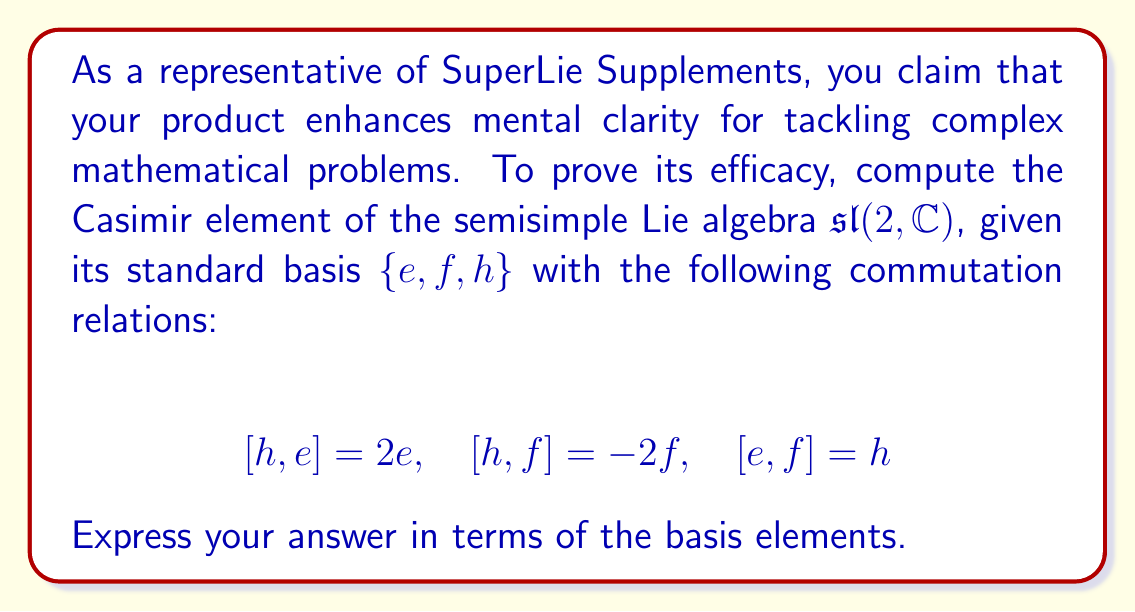Show me your answer to this math problem. To compute the Casimir element of $\mathfrak{sl}(2,\mathbb{C})$, we follow these steps:

1) First, we need to determine the Killing form $B(x,y)$ for this Lie algebra. For $\mathfrak{sl}(2,\mathbb{C})$, the Killing form is given by:

   $$B(x,y) = 4\mathrm{Tr}(\mathrm{ad}(x)\mathrm{ad}(y))$$

2) We calculate the matrix of the Killing form with respect to the given basis $\{e,f,h\}$:

   $$B(h,h) = 8, \quad B(e,f) = B(f,e) = 4, \quad B(h,e) = B(h,f) = B(e,h) = B(f,h) = 0$$

3) The inverse of this matrix is:

   $$B^{-1} = \frac{1}{8}\begin{pmatrix}
   0 & 2 & 0 \\
   2 & 0 & 0 \\
   0 & 0 & 1
   \end{pmatrix}$$

4) The Casimir element $C$ is given by:

   $$C = \sum_{i,j} B^{ij}x_i x_j$$

   where $B^{ij}$ are the entries of the inverse Killing form matrix and $x_i$ are the basis elements.

5) Substituting the values:

   $$C = \frac{1}{8}(2ef + 2fe + h^2)$$

6) Using the relation $[e,f] = h$, we can write $fe = ef - h$. Substituting this:

   $$C = \frac{1}{8}(2ef + 2(ef-h) + h^2) = \frac{1}{8}(4ef - 2h + h^2)$$

7) Simplifying:

   $$C = \frac{1}{2}ef - \frac{1}{4}h + \frac{1}{8}h^2$$
Answer: The Casimir element of $\mathfrak{sl}(2,\mathbb{C})$ is:

$$C = \frac{1}{2}ef - \frac{1}{4}h + \frac{1}{8}h^2$$ 